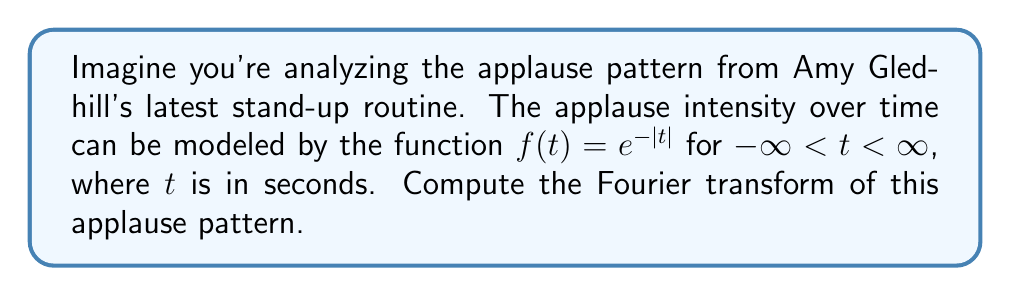Show me your answer to this math problem. Let's approach this step-by-step:

1) The Fourier transform of a function $f(t)$ is defined as:

   $$F(\omega) = \int_{-\infty}^{\infty} f(t) e^{-i\omega t} dt$$

2) In our case, $f(t) = e^{-|t|}$. We need to split the integral due to the absolute value:

   $$F(\omega) = \int_{-\infty}^{0} e^{t} e^{-i\omega t} dt + \int_{0}^{\infty} e^{-t} e^{-i\omega t} dt$$

3) Let's solve the first integral:

   $$I_1 = \int_{-\infty}^{0} e^{t} e^{-i\omega t} dt = \int_{-\infty}^{0} e^{(1-i\omega)t} dt = \frac{e^{(1-i\omega)t}}{1-i\omega} \bigg|_{-\infty}^{0} = \frac{1}{1-i\omega}$$

4) Now the second integral:

   $$I_2 = \int_{0}^{\infty} e^{-t} e^{-i\omega t} dt = \int_{0}^{\infty} e^{-(1+i\omega)t} dt = \frac{-e^{-(1+i\omega)t}}{1+i\omega} \bigg|_{0}^{\infty} = \frac{1}{1+i\omega}$$

5) The Fourier transform is the sum of these integrals:

   $$F(\omega) = I_1 + I_2 = \frac{1}{1-i\omega} + \frac{1}{1+i\omega}$$

6) Find a common denominator:

   $$F(\omega) = \frac{1+i\omega}{(1-i\omega)(1+i\omega)} + \frac{1-i\omega}{(1-i\omega)(1+i\omega)} = \frac{2}{1+\omega^2}$$

This is the Fourier transform of the applause pattern.
Answer: $$F(\omega) = \frac{2}{1+\omega^2}$$ 